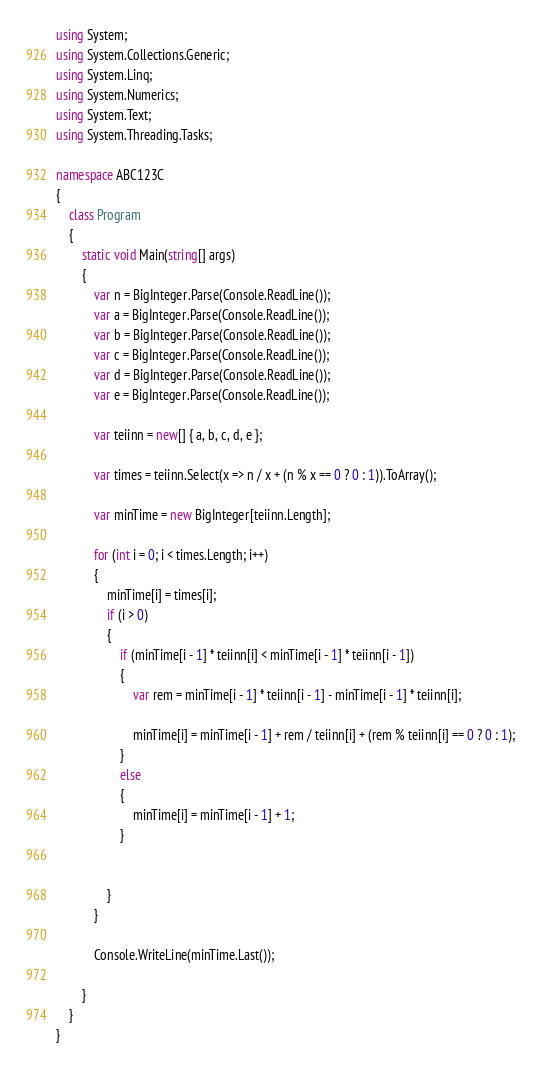<code> <loc_0><loc_0><loc_500><loc_500><_C#_>using System;
using System.Collections.Generic;
using System.Linq;
using System.Numerics;
using System.Text;
using System.Threading.Tasks;

namespace ABC123C
{
    class Program
    {
        static void Main(string[] args)
        {
            var n = BigInteger.Parse(Console.ReadLine());
            var a = BigInteger.Parse(Console.ReadLine());
            var b = BigInteger.Parse(Console.ReadLine());
            var c = BigInteger.Parse(Console.ReadLine());
            var d = BigInteger.Parse(Console.ReadLine());
            var e = BigInteger.Parse(Console.ReadLine());

            var teiinn = new[] { a, b, c, d, e };

            var times = teiinn.Select(x => n / x + (n % x == 0 ? 0 : 1)).ToArray();

            var minTime = new BigInteger[teiinn.Length];

            for (int i = 0; i < times.Length; i++)
            {
                minTime[i] = times[i];
                if (i > 0)
                {
                    if (minTime[i - 1] * teiinn[i] < minTime[i - 1] * teiinn[i - 1])
                    {
                        var rem = minTime[i - 1] * teiinn[i - 1] - minTime[i - 1] * teiinn[i];

                        minTime[i] = minTime[i - 1] + rem / teiinn[i] + (rem % teiinn[i] == 0 ? 0 : 1);
                    }
                    else
                    {
                        minTime[i] = minTime[i - 1] + 1;
                    }


                }
            }

            Console.WriteLine(minTime.Last());

        }
    }
}
</code> 